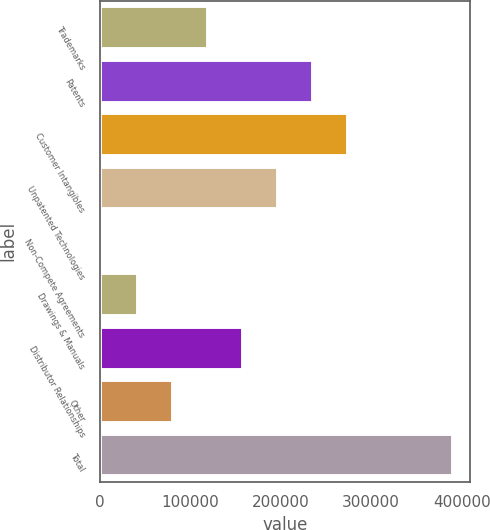Convert chart. <chart><loc_0><loc_0><loc_500><loc_500><bar_chart><fcel>Trademarks<fcel>Patents<fcel>Customer Intangibles<fcel>Unpatented Technologies<fcel>Non-Compete Agreements<fcel>Drawings & Manuals<fcel>Distributor Relationships<fcel>Other<fcel>Total<nl><fcel>119391<fcel>235383<fcel>274047<fcel>196719<fcel>3400<fcel>42063.8<fcel>158055<fcel>80727.6<fcel>390038<nl></chart> 